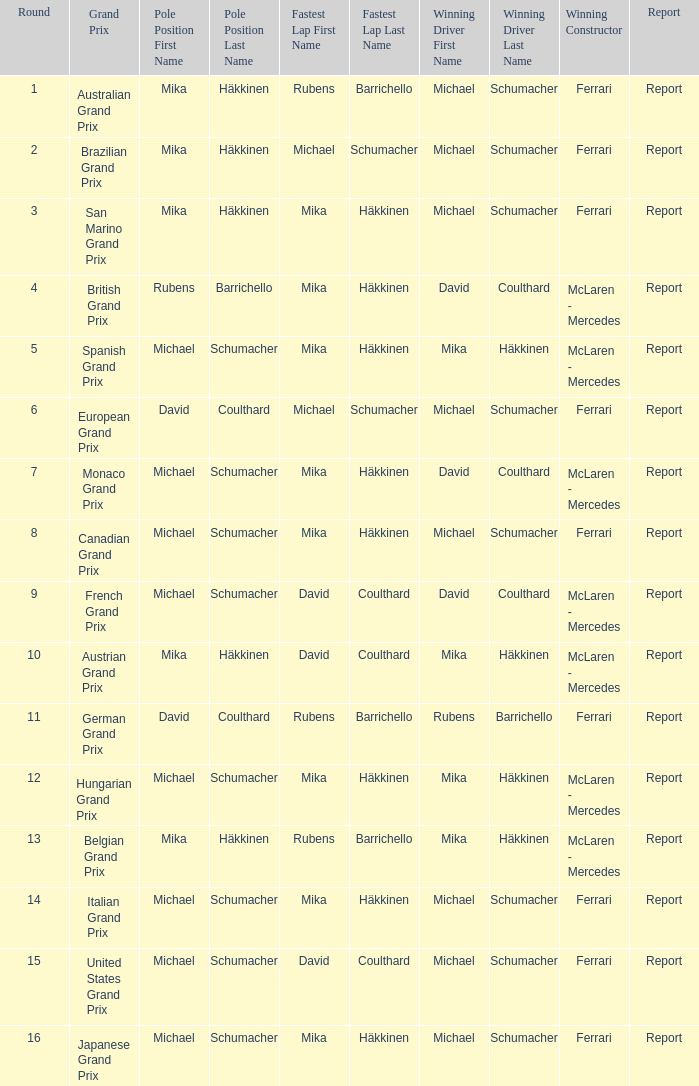How many competitors secured a win in the italian grand prix? 1.0. 